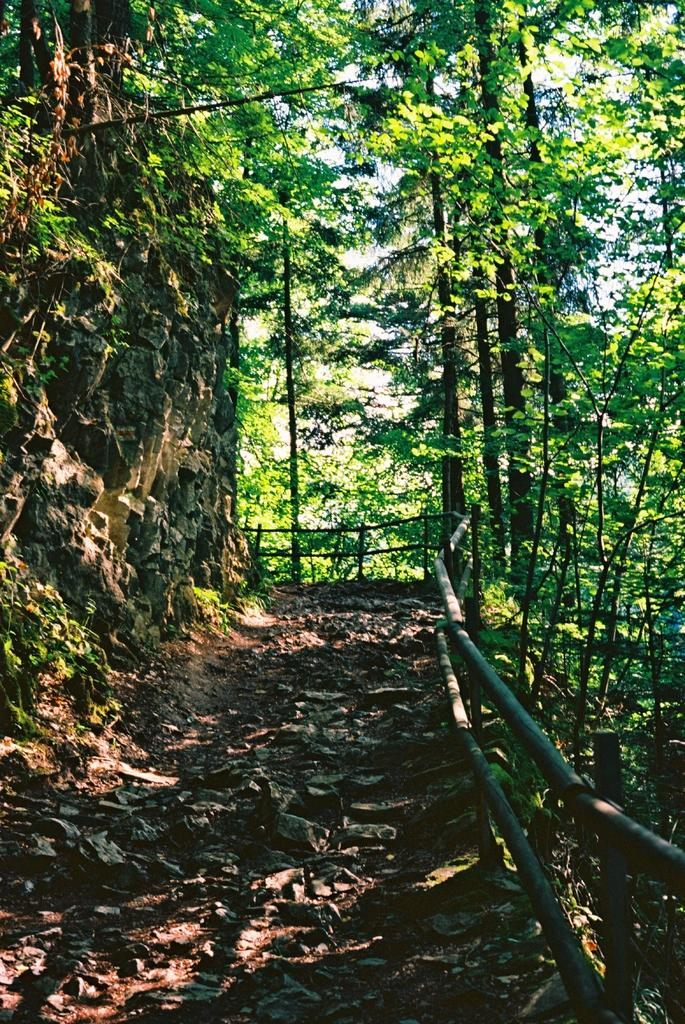What type of environment is shown in the image? The image depicts a forest. Can you describe any specific features within the forest? There is a rock in the forest. What is located near the rock? There is a path filled with leaves and sand beside the rock. What type of barrier surrounds the path? The path has a wooden fence surrounding it. Where can the basin be found in the image? There is no basin present in the image. Can you describe the texture of the cherries in the image? There are no cherries present in the image. 